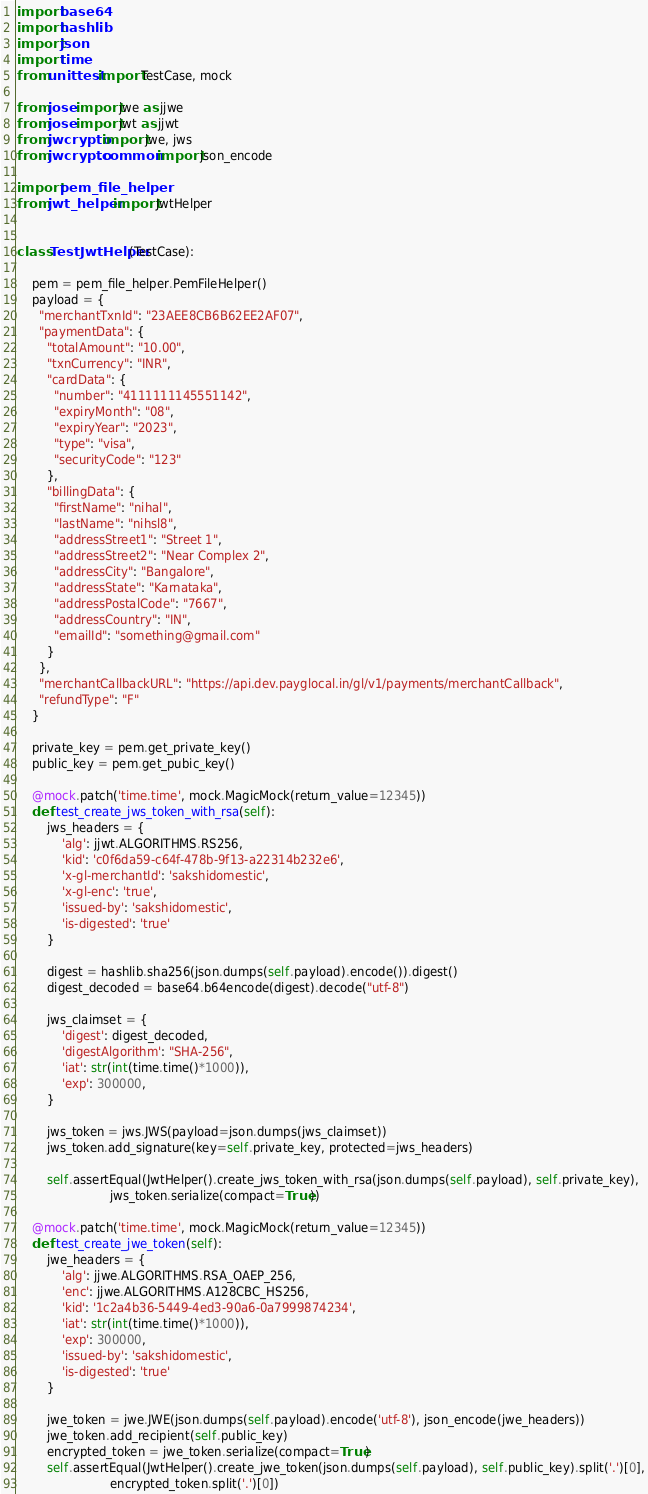<code> <loc_0><loc_0><loc_500><loc_500><_Python_>import base64
import hashlib
import json
import time
from unittest import TestCase, mock

from jose import jwe as jjwe
from jose import jwt as jjwt
from jwcrypto import jwe, jws
from jwcrypto.common import json_encode

import pem_file_helper
from jwt_helper import JwtHelper


class TestJwtHelper(TestCase):

    pem = pem_file_helper.PemFileHelper()
    payload = {
      "merchantTxnId": "23AEE8CB6B62EE2AF07",
      "paymentData": {
        "totalAmount": "10.00",
        "txnCurrency": "INR",
        "cardData": {
          "number": "4111111145551142",
          "expiryMonth": "08",
          "expiryYear": "2023",
          "type": "visa",
          "securityCode": "123"
        },
        "billingData": {
          "firstName": "nihal",
          "lastName": "nihsl8",
          "addressStreet1": "Street 1",
          "addressStreet2": "Near Complex 2",
          "addressCity": "Bangalore",
          "addressState": "Karnataka",
          "addressPostalCode": "7667",
          "addressCountry": "IN",
          "emailId": "something@gmail.com"
        }
      },
      "merchantCallbackURL": "https://api.dev.payglocal.in/gl/v1/payments/merchantCallback",
      "refundType": "F"
    }

    private_key = pem.get_private_key()
    public_key = pem.get_pubic_key()

    @mock.patch('time.time', mock.MagicMock(return_value=12345))
    def test_create_jws_token_with_rsa(self):
        jws_headers = {
            'alg': jjwt.ALGORITHMS.RS256,
            'kid': 'c0f6da59-c64f-478b-9f13-a22314b232e6',
            'x-gl-merchantId': 'sakshidomestic',
            'x-gl-enc': 'true',
            'issued-by': 'sakshidomestic',
            'is-digested': 'true'
        }

        digest = hashlib.sha256(json.dumps(self.payload).encode()).digest()
        digest_decoded = base64.b64encode(digest).decode("utf-8")

        jws_claimset = {
            'digest': digest_decoded,
            'digestAlgorithm': "SHA-256",
            'iat': str(int(time.time()*1000)),
            'exp': 300000,
        }

        jws_token = jws.JWS(payload=json.dumps(jws_claimset))
        jws_token.add_signature(key=self.private_key, protected=jws_headers)

        self.assertEqual(JwtHelper().create_jws_token_with_rsa(json.dumps(self.payload), self.private_key),
                         jws_token.serialize(compact=True))

    @mock.patch('time.time', mock.MagicMock(return_value=12345))
    def test_create_jwe_token(self):
        jwe_headers = {
            'alg': jjwe.ALGORITHMS.RSA_OAEP_256,
            'enc': jjwe.ALGORITHMS.A128CBC_HS256,
            'kid': '1c2a4b36-5449-4ed3-90a6-0a7999874234',
            'iat': str(int(time.time()*1000)),
            'exp': 300000,
            'issued-by': 'sakshidomestic',
            'is-digested': 'true'
        }

        jwe_token = jwe.JWE(json.dumps(self.payload).encode('utf-8'), json_encode(jwe_headers))
        jwe_token.add_recipient(self.public_key)
        encrypted_token = jwe_token.serialize(compact=True)
        self.assertEqual(JwtHelper().create_jwe_token(json.dumps(self.payload), self.public_key).split('.')[0],
                         encrypted_token.split('.')[0])
</code> 